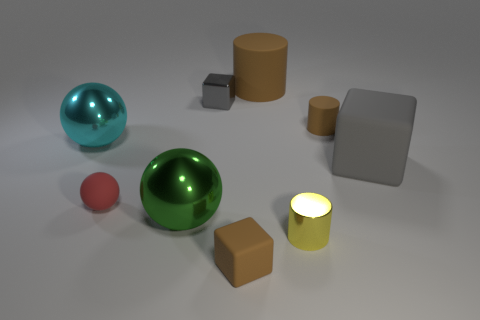Subtract all gray cubes. How many were subtracted if there are1gray cubes left? 1 Subtract 1 blocks. How many blocks are left? 2 Add 1 big gray rubber cubes. How many objects exist? 10 Subtract all cylinders. How many objects are left? 6 Add 6 red matte balls. How many red matte balls exist? 7 Subtract 0 yellow spheres. How many objects are left? 9 Subtract all tiny red objects. Subtract all tiny gray blocks. How many objects are left? 7 Add 5 big brown matte cylinders. How many big brown matte cylinders are left? 6 